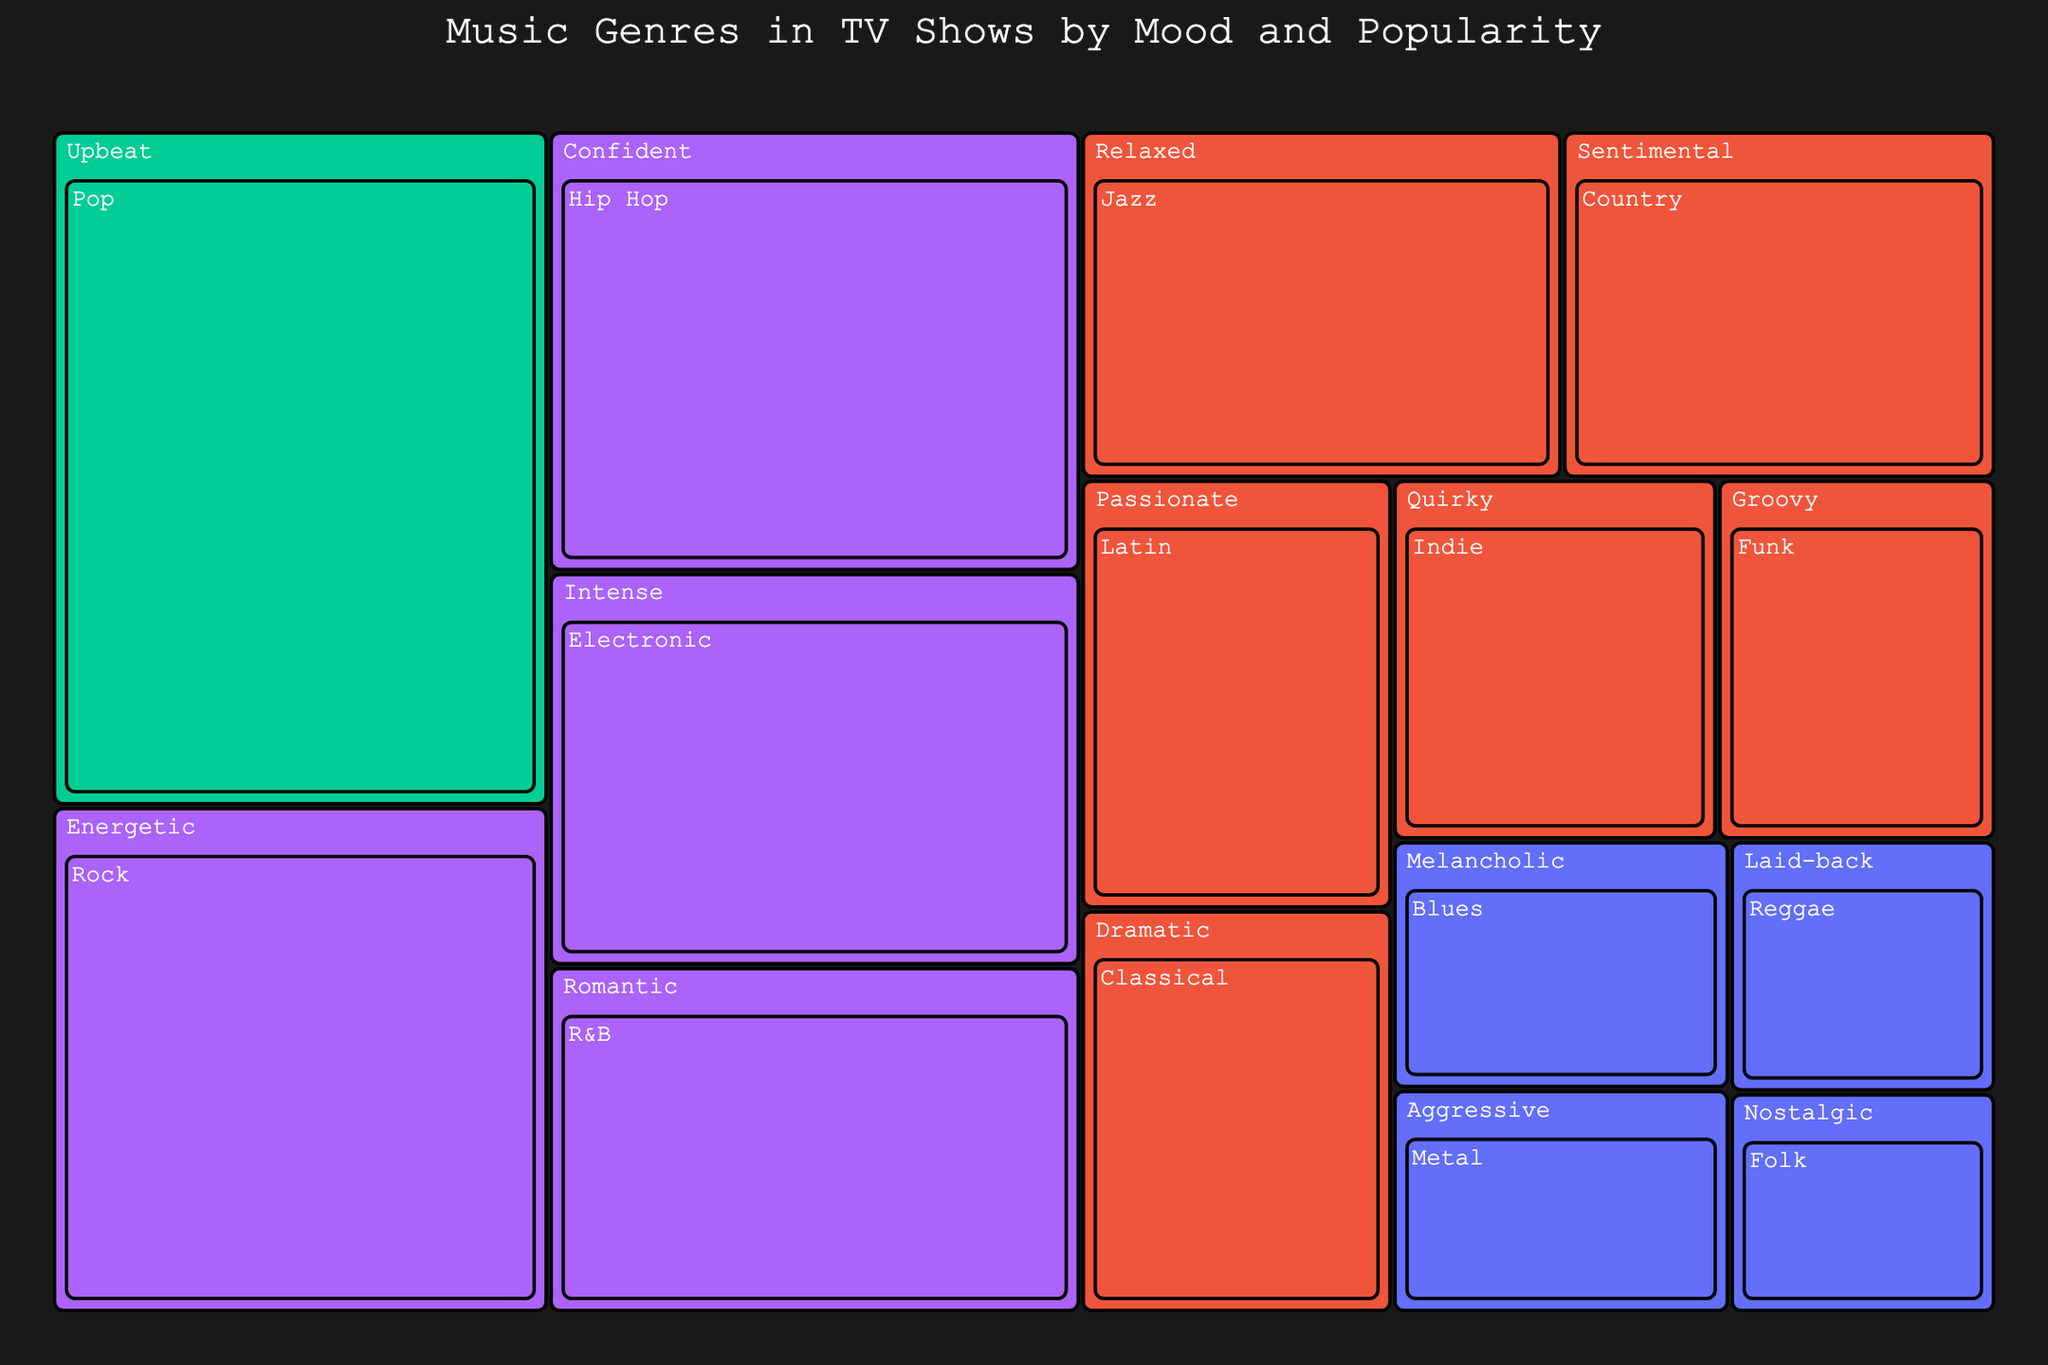What's the title of the figure? The title is typically located at the upper section of the figure. In this Treemap, it reads "Music Genres in TV Shows by Mood and Popularity".
Answer: Music Genres in TV Shows by Mood and Popularity Which music genre has the highest value? From the Treemap, by comparing the size of the rectangles, the genre labeled "Pop" stands out as the largest, which indicates it has the highest value.
Answer: Pop Which mood category contains the most genres? Identify the number of unique genres listed under each mood category in the Treemap. The "Medium" mood contains genres like Jazz, Classical, Country, Funk, Indie, and Latin, which total to six genres, more than any other mood category.
Answer: Medium Compare the values of "Hip Hop" and "Indie". Which is higher? Look at the relative size and values of the rectangles for "Hip Hop" and "Indie" within the "Confident" and "Quirky" mood categories, respectively. "Hip Hop" has a value of 28 while "Indie" has a value of 14, making "Hip Hop" the higher value.
Answer: Hip Hop What is the combined value of "Blues" and "Reggae"? To find the total value, sum the individual values of "Blues" and "Reggae". Blues has a value of 10 and Reggae has a value of 8; thus, the combined value is 10 + 8.
Answer: 18 Which genre in the "Medium" popularity category has the lowest value? Examine the subrectangles within the "Medium" popularity category. Out of Jazz (20), Classical (15), Country (18), Indie (14), Funk (12), and Latin (16), Funk has the smallest size and the lowest value.
Answer: Funk What is the most popular music genre associated with the "Upbeat" mood? The popularity of genres is visually coded with a continuous color scale, with more popular genres closer to one end. In the "Upbeat" mood, "Pop" is indicated with "Very High" popularity.
Answer: Pop How does the popularity of "Electronic" compare to "Rock"? Check the color gradient associated with both genres. Both "Electronic" and "Rock" are in the "High" popularity spectrum, indicating a similar popularity level.
Answer: Similar What genres fall under the "Low" popularity level, and what are their values? Locate the genres with a darker color indicative of lower popularity. The genres are "Blues" (10), "Reggae" (8), "Folk" (7), and "Metal" (9). List each with their corresponding values.
Answer: Blues (10), Reggae (8), Folk (7), Metal (9) 